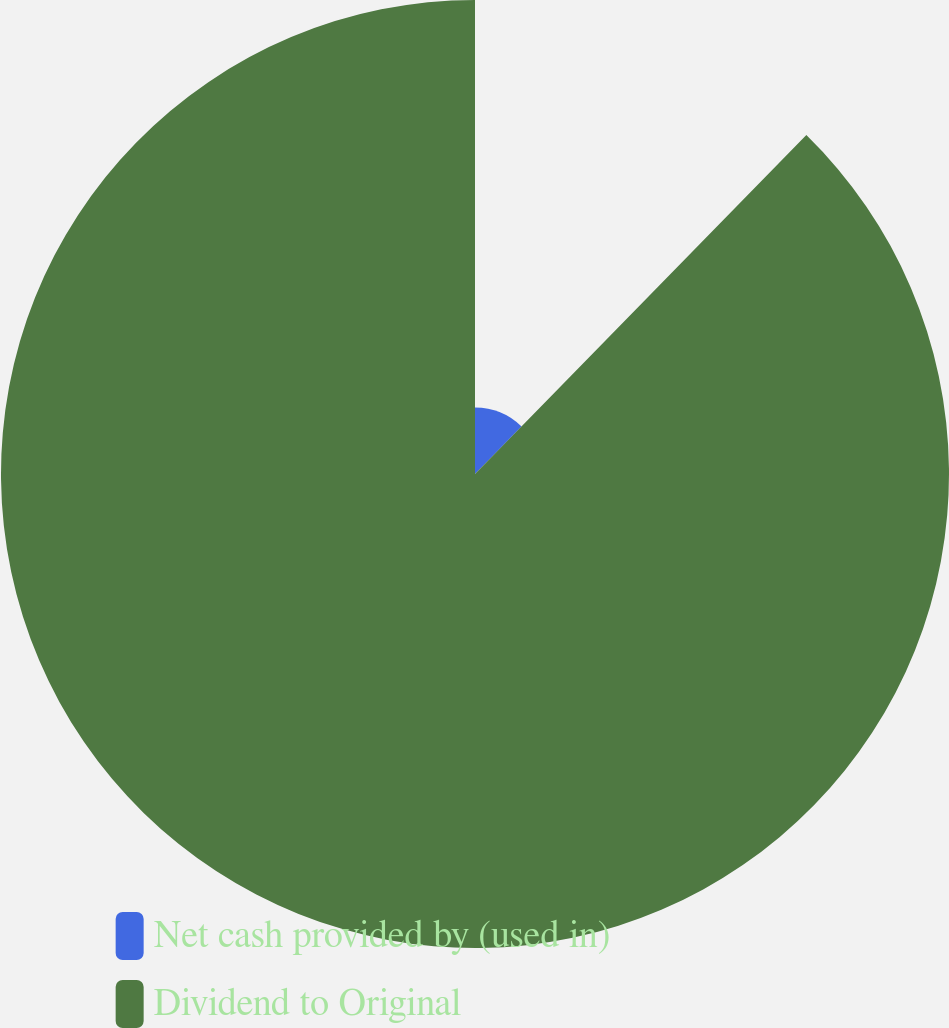Convert chart to OTSL. <chart><loc_0><loc_0><loc_500><loc_500><pie_chart><fcel>Net cash provided by (used in)<fcel>Dividend to Original<nl><fcel>12.32%<fcel>87.68%<nl></chart> 